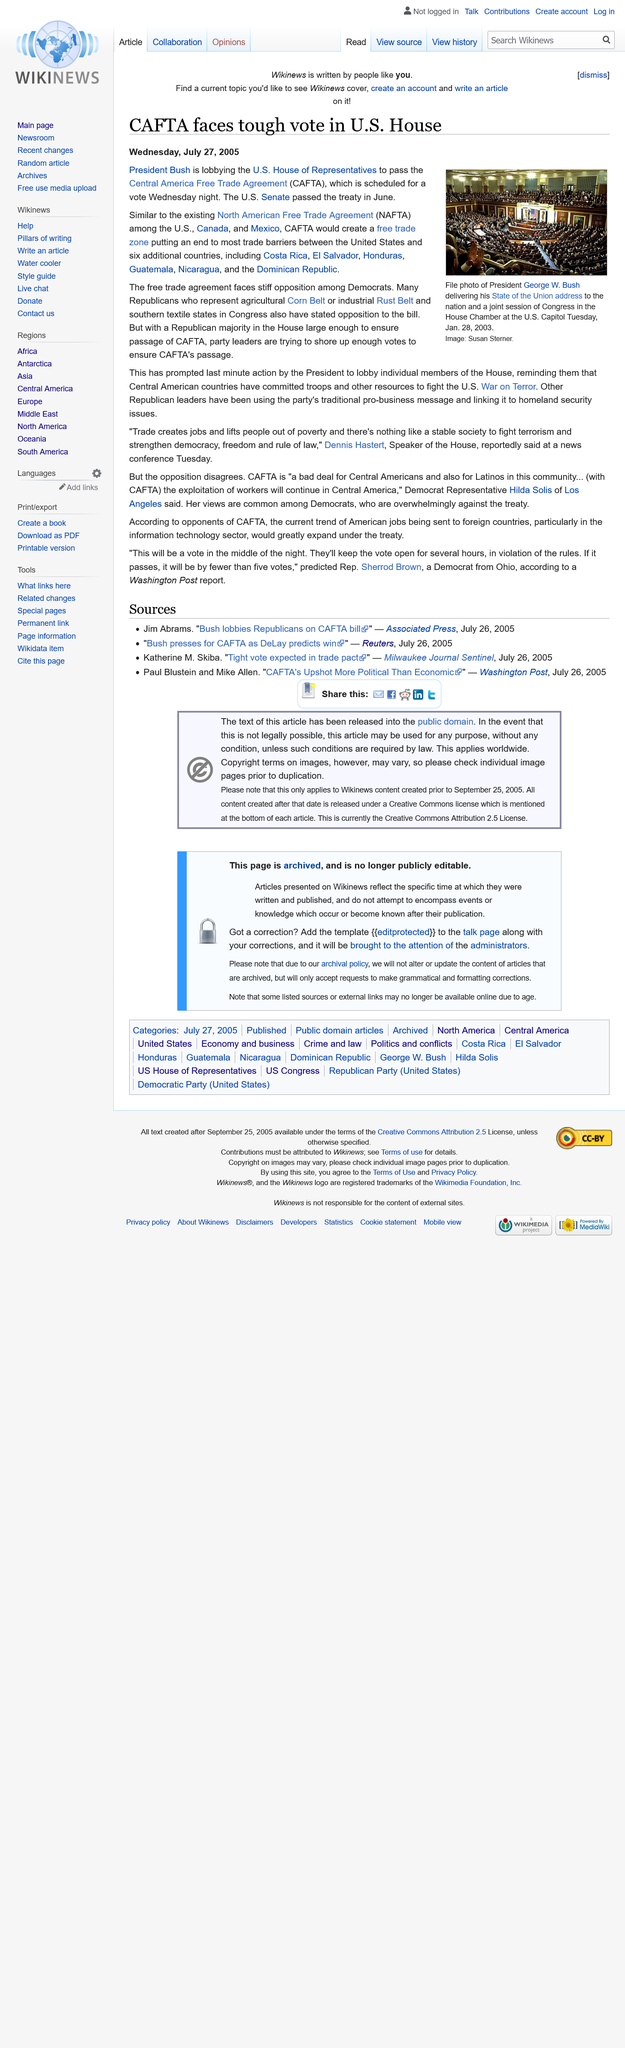Specify some key components in this picture. President Bush is actively lobbying the U.S. House of Representatives to pass CAFTA, however, the Democrats strongly oppose this legislation. CAFTA, the Central American Free Trade Agreement, will provide significant benefits to Costa Rica, El Salvador, Honduras, Guatemala, Nicaragua, and the Dominican Republic, as these six countries will enjoy reduced trade barriers and increased economic opportunities with the United States and other CAFTA signatories. The Central America Free Trade Agreement, commonly abbreviated as CAFTA, is an agreement between several countries in Central America and the United States that aims to reduce trade barriers and promote economic growth. 